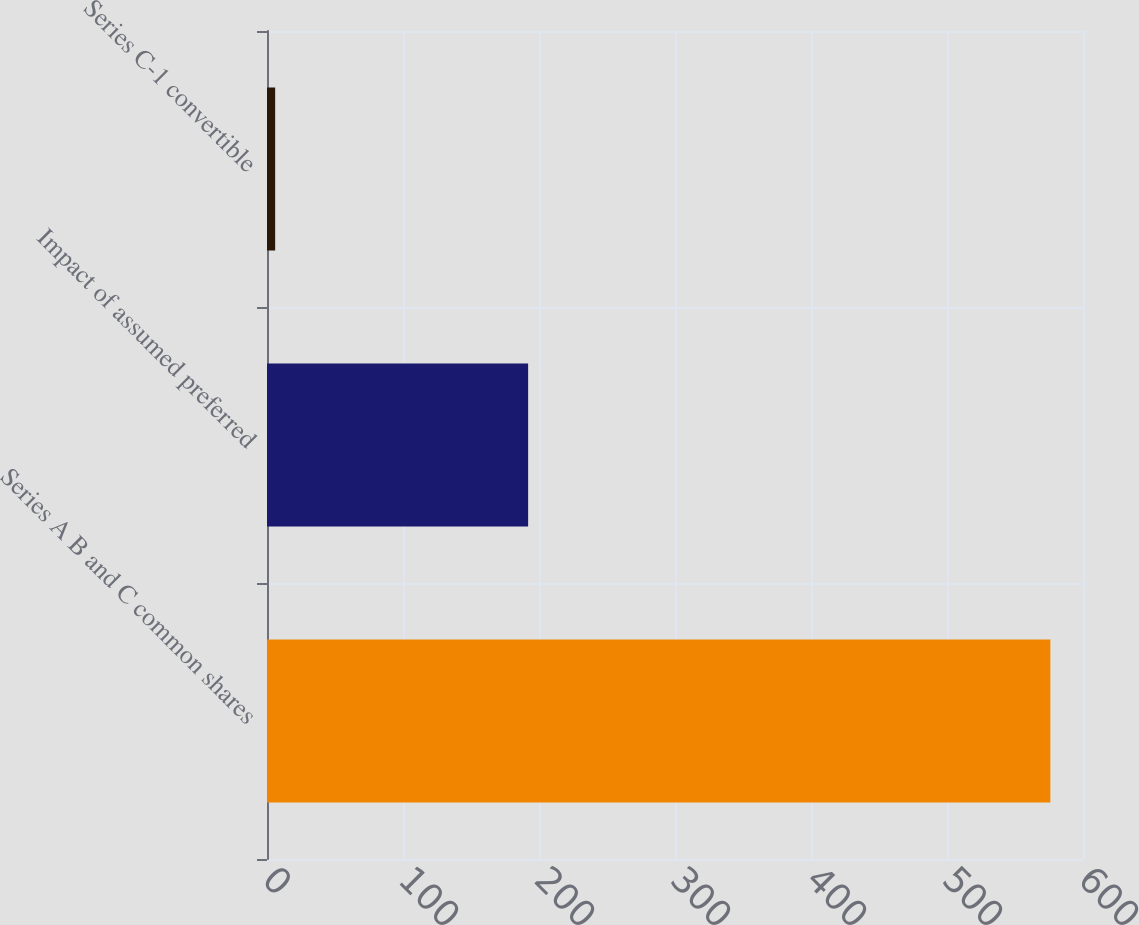<chart> <loc_0><loc_0><loc_500><loc_500><bar_chart><fcel>Series A B and C common shares<fcel>Impact of assumed preferred<fcel>Series C-1 convertible<nl><fcel>576<fcel>192<fcel>6<nl></chart> 